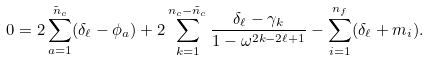Convert formula to latex. <formula><loc_0><loc_0><loc_500><loc_500>0 = 2 \sum _ { a = 1 } ^ { \tilde { n } _ { c } } ( \delta _ { \ell } - \phi _ { a } ) + 2 \sum _ { k = 1 } ^ { n _ { c } - \tilde { n } _ { c } } \frac { \delta _ { \ell } - \gamma _ { k } } { 1 - \omega ^ { 2 k - 2 \ell + 1 } } - \sum _ { i = 1 } ^ { n _ { f } } ( \delta _ { \ell } + m _ { i } ) .</formula> 